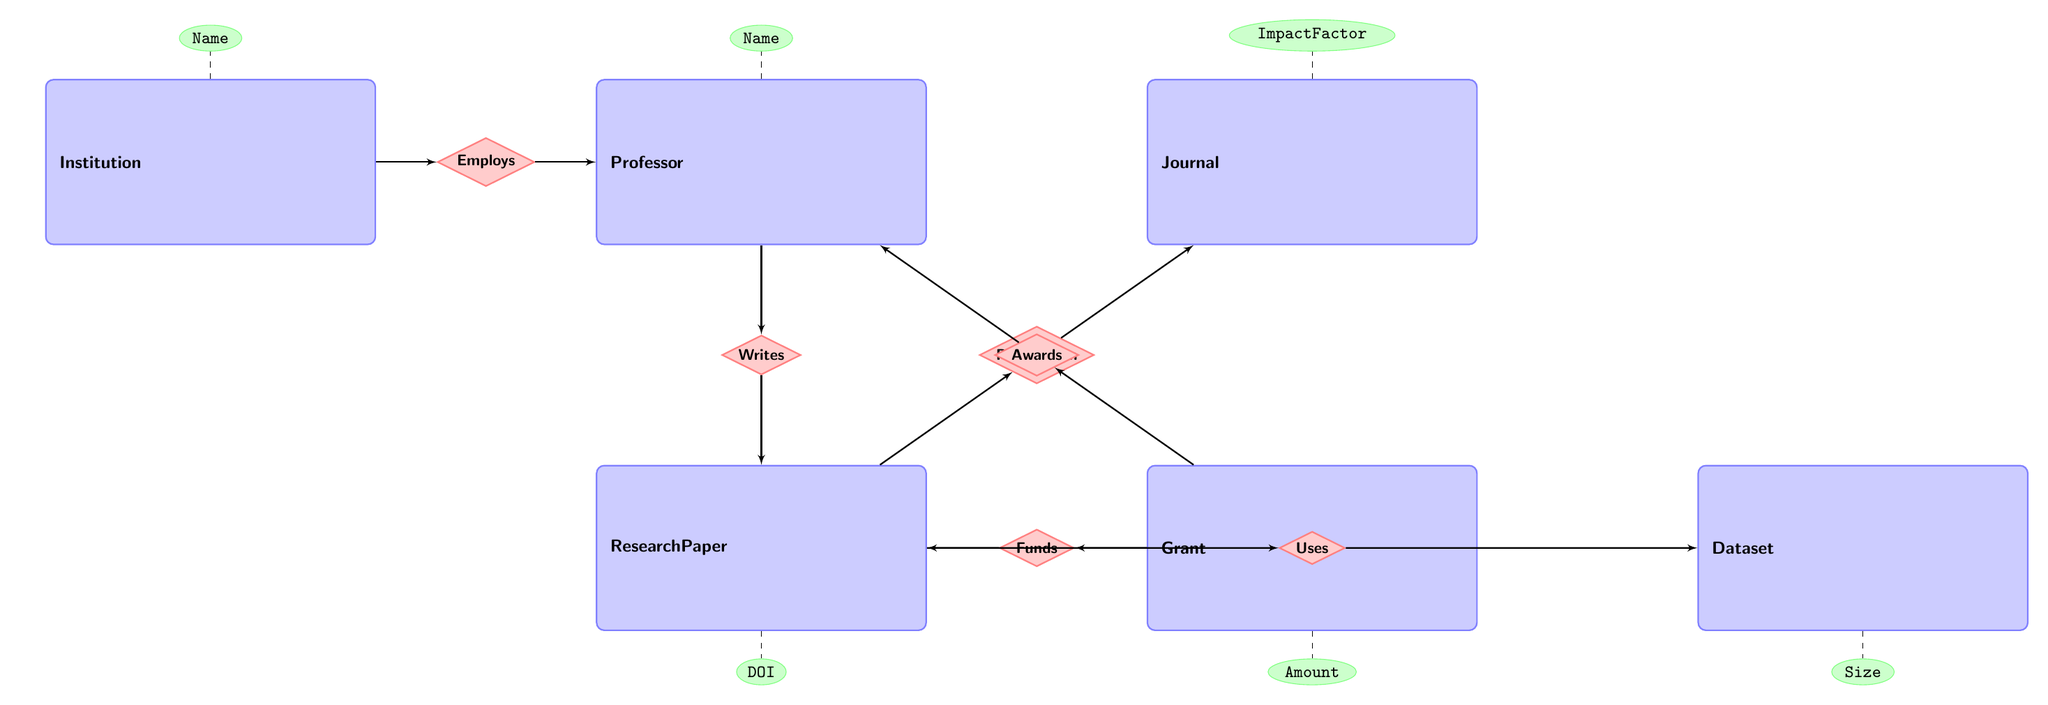What is the relationship between Professor and ResearchPaper? The relationship is indicated as "Writes" in the diagram, which shows that a Professor authors or writes Research Papers.
Answer: Writes How many entities are in the diagram? By counting the distinct entities shown, we find that there are six entities: Professor, Journal, ResearchPaper, Grant, Institution, and Dataset.
Answer: Six What attribute does the Journal entity include that indicates its influence? The Journal entity includes the attribute "ImpactFactor," which reflects the journal's reliability and influence in scholarly publishing.
Answer: ImpactFactor What relationship connects ResearchPaper and Dataset? The relationship between ResearchPaper and Dataset is identified as "Uses", which indicates that a ResearchPaper utilizes data from a Dataset.
Answer: Uses Which entity has a relationship that involves funding? The Grant entity has a relationship identified as "Funds" that connects it to ResearchPaper, indicating that Grants provide financial support for the research documented in Research Papers.
Answer: Grant Which attribute describes the size of a Dataset? The attribute that describes the size of a Dataset is "Size", as represented in the diagram.
Answer: Size What is the relationship between Grant and Professor? The relationship is indicated as "Awards," meaning that Grants are awarded to Professors in recognition of their research contributions.
Answer: Awards What is the relationship between ResearchPaper and Journal? The relationship is labeled as "PublishedIn," denoting that a ResearchPaper gets published in a Journal.
Answer: PublishedIn Which entity has a direct connection to the Employs relationship? The Institution entity directly connects with the Employs relationship, indicating that it employs Professors.
Answer: Institution 